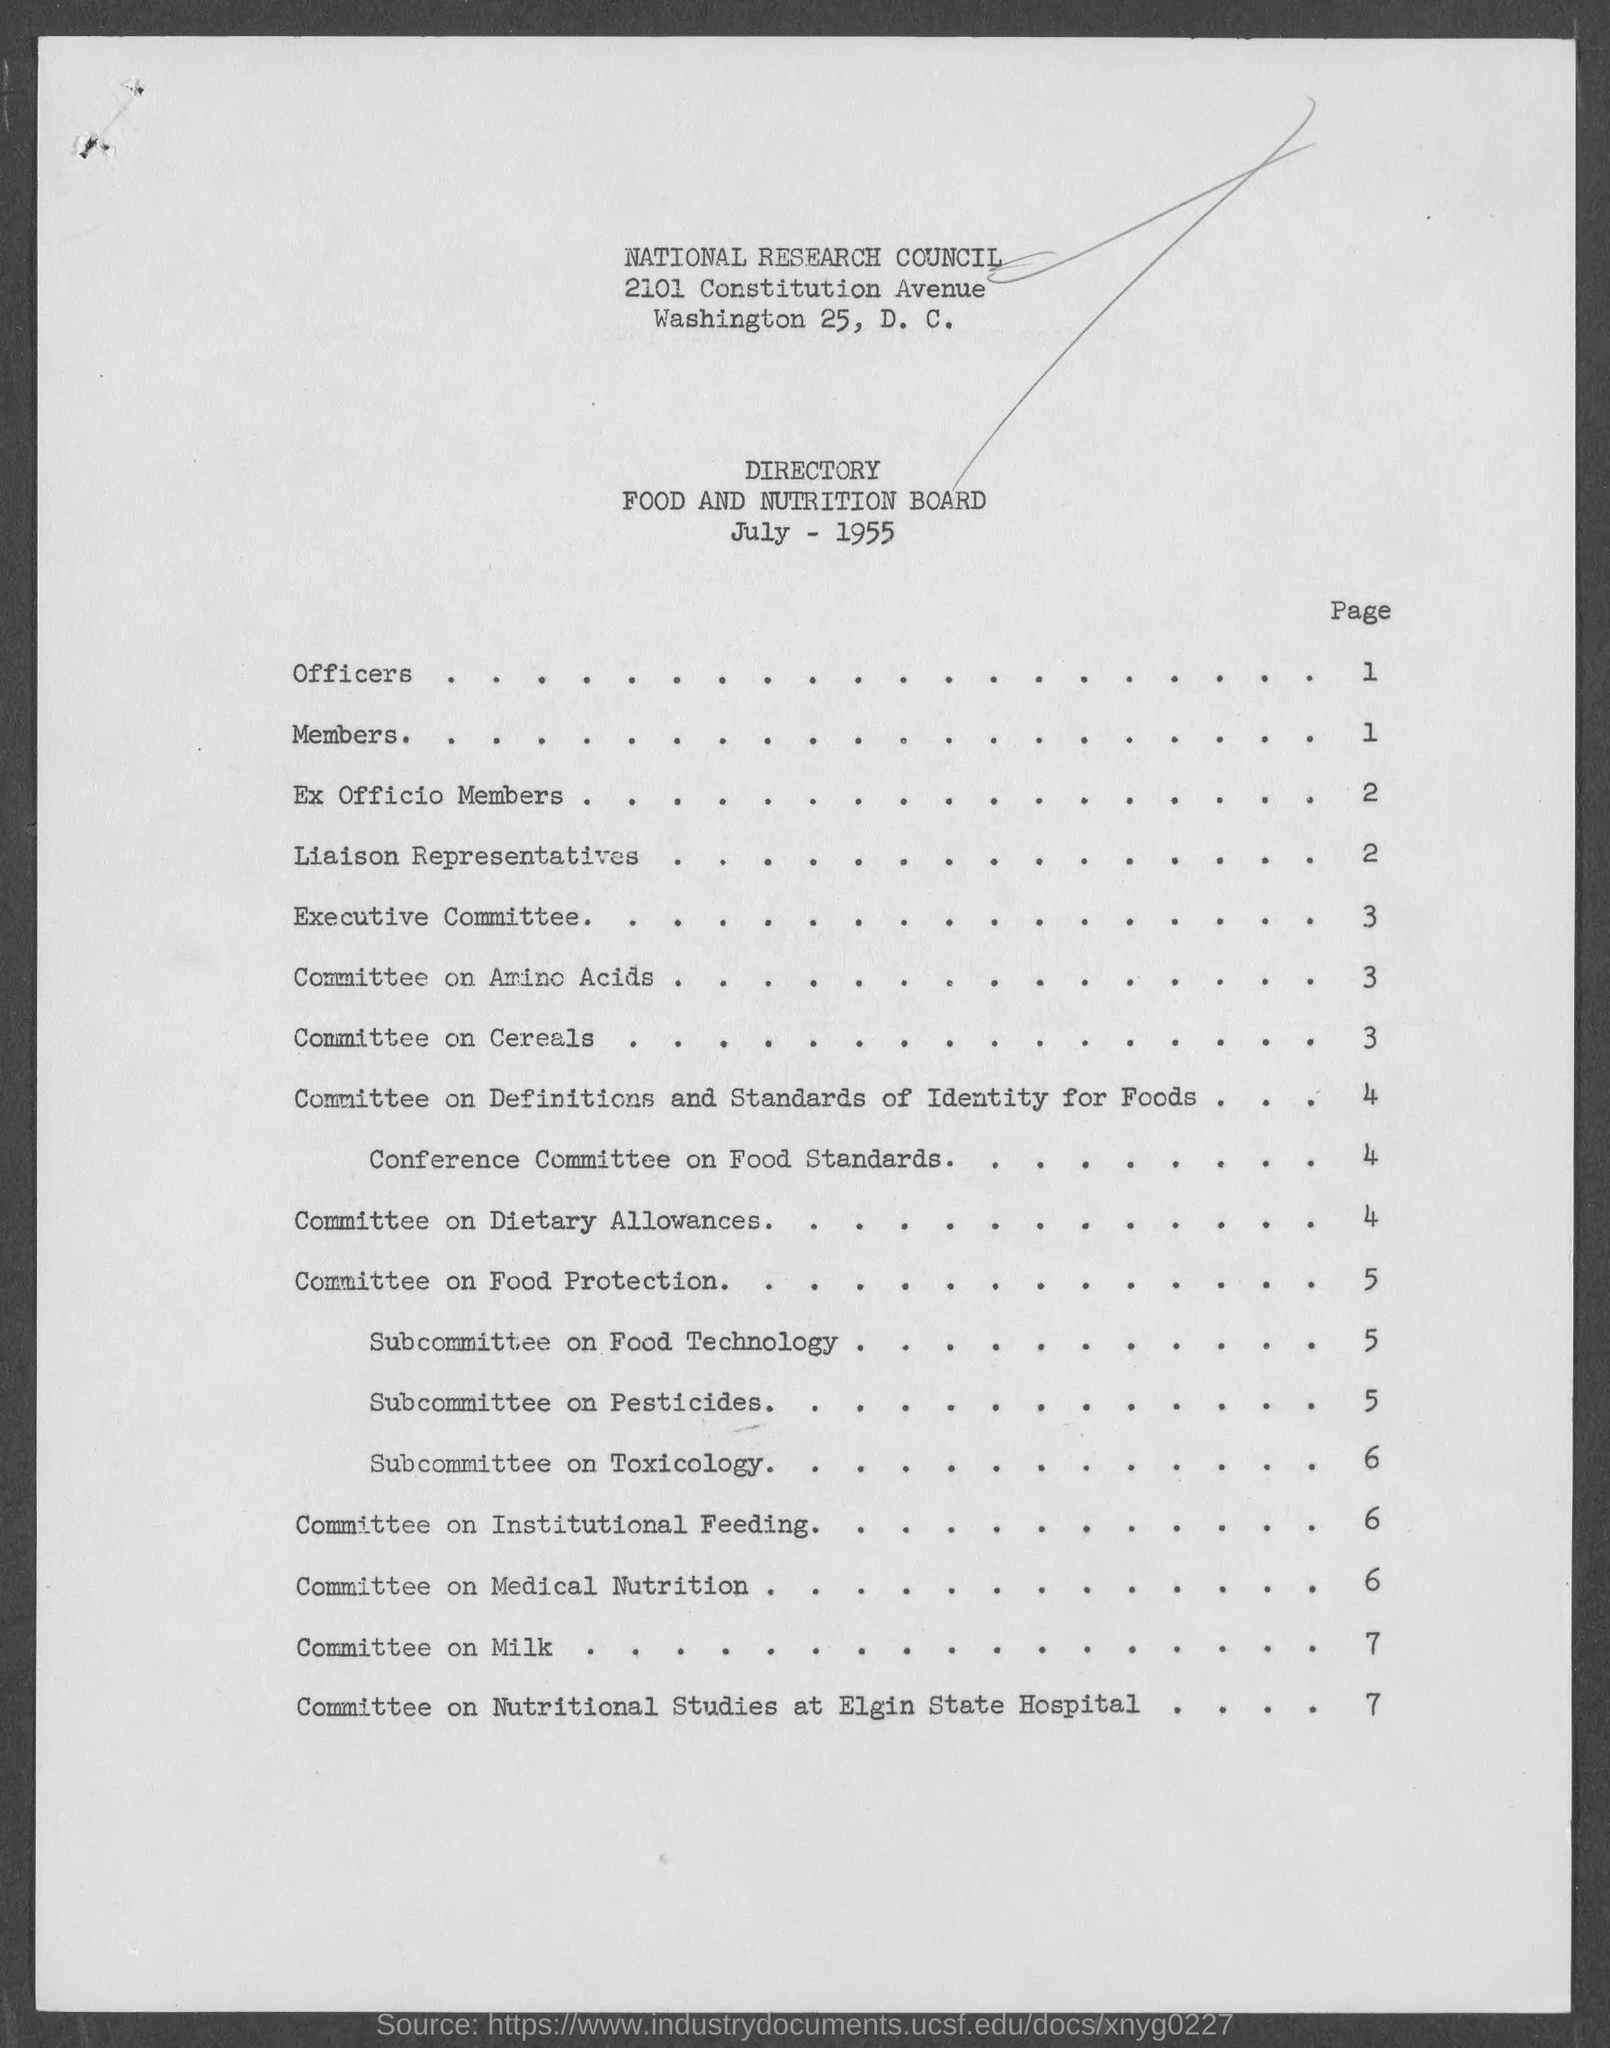In which page number is  "Members"?
Keep it short and to the point. 1. In which page number is "Executive Committee"?
Offer a terse response. 3. In which page number is  "Committee on Amino Acids"?
Ensure brevity in your answer.  3. In which page number is "Committee on Milk"?
Your answer should be compact. 7. 